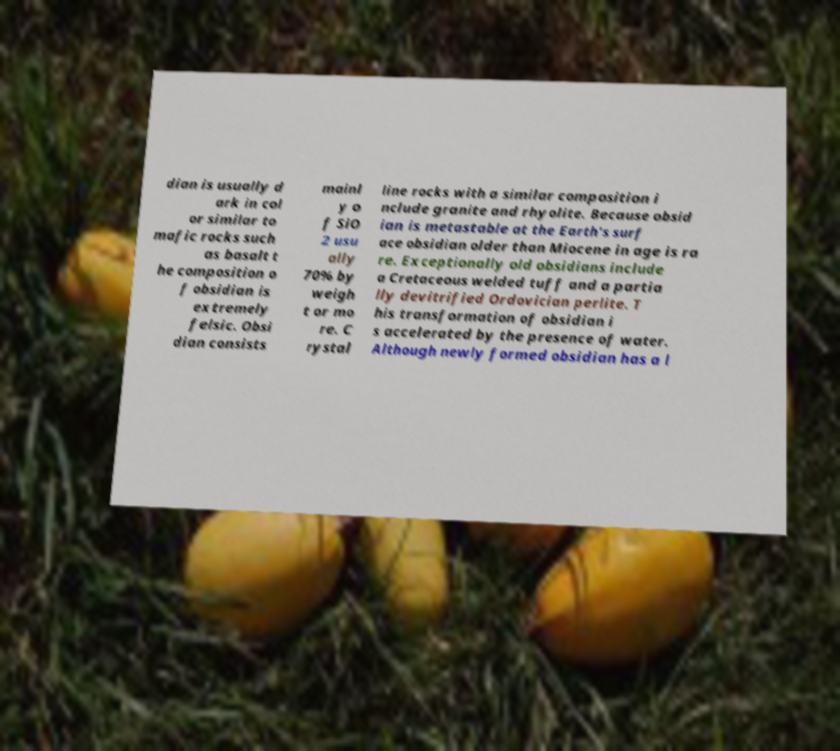There's text embedded in this image that I need extracted. Can you transcribe it verbatim? dian is usually d ark in col or similar to mafic rocks such as basalt t he composition o f obsidian is extremely felsic. Obsi dian consists mainl y o f SiO 2 usu ally 70% by weigh t or mo re. C rystal line rocks with a similar composition i nclude granite and rhyolite. Because obsid ian is metastable at the Earth's surf ace obsidian older than Miocene in age is ra re. Exceptionally old obsidians include a Cretaceous welded tuff and a partia lly devitrified Ordovician perlite. T his transformation of obsidian i s accelerated by the presence of water. Although newly formed obsidian has a l 